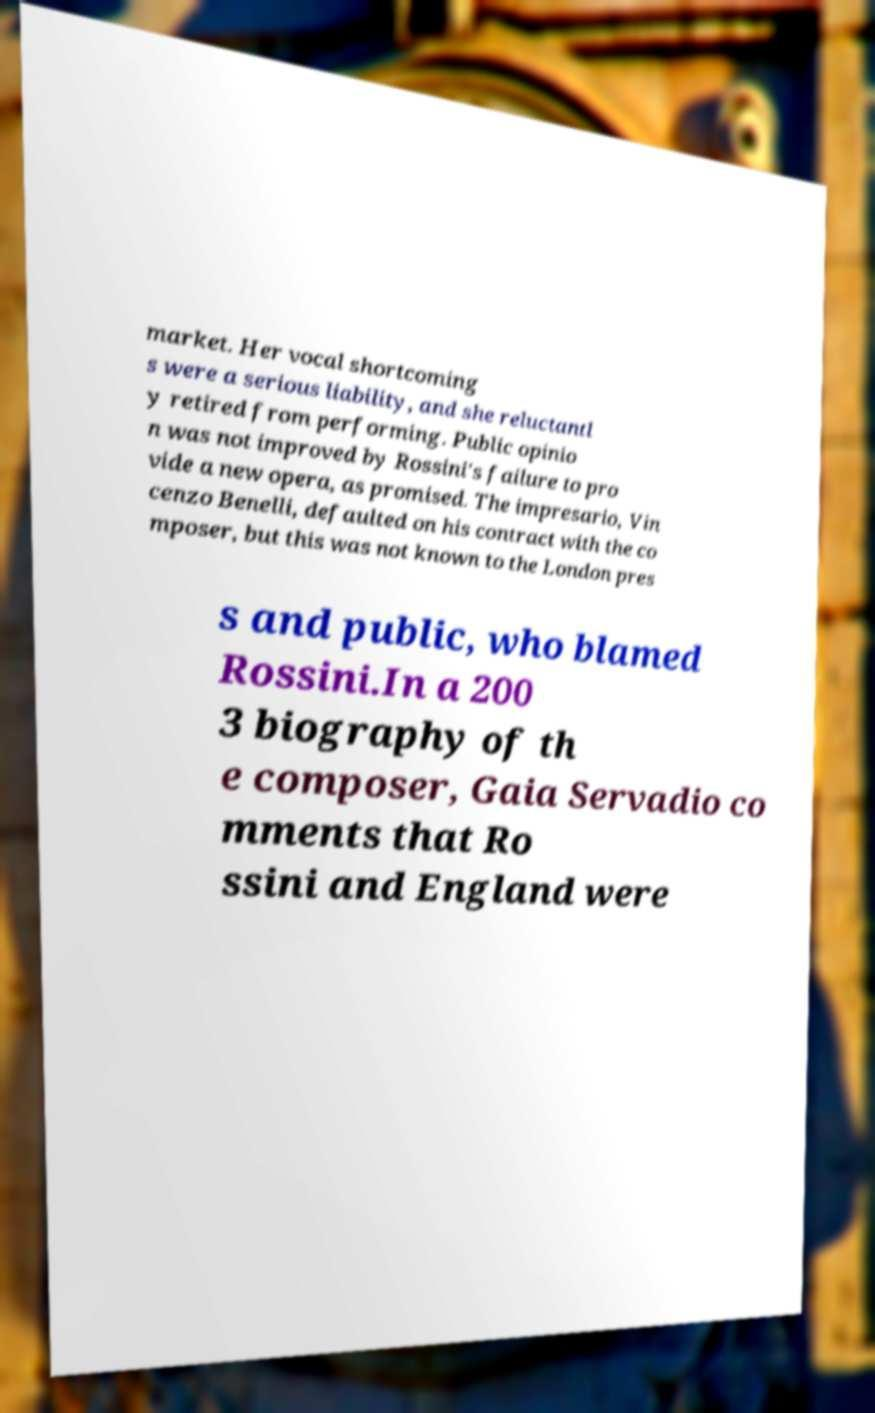I need the written content from this picture converted into text. Can you do that? market. Her vocal shortcoming s were a serious liability, and she reluctantl y retired from performing. Public opinio n was not improved by Rossini's failure to pro vide a new opera, as promised. The impresario, Vin cenzo Benelli, defaulted on his contract with the co mposer, but this was not known to the London pres s and public, who blamed Rossini.In a 200 3 biography of th e composer, Gaia Servadio co mments that Ro ssini and England were 